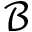Convert formula to latex. <formula><loc_0><loc_0><loc_500><loc_500>\mathcal { B }</formula> 